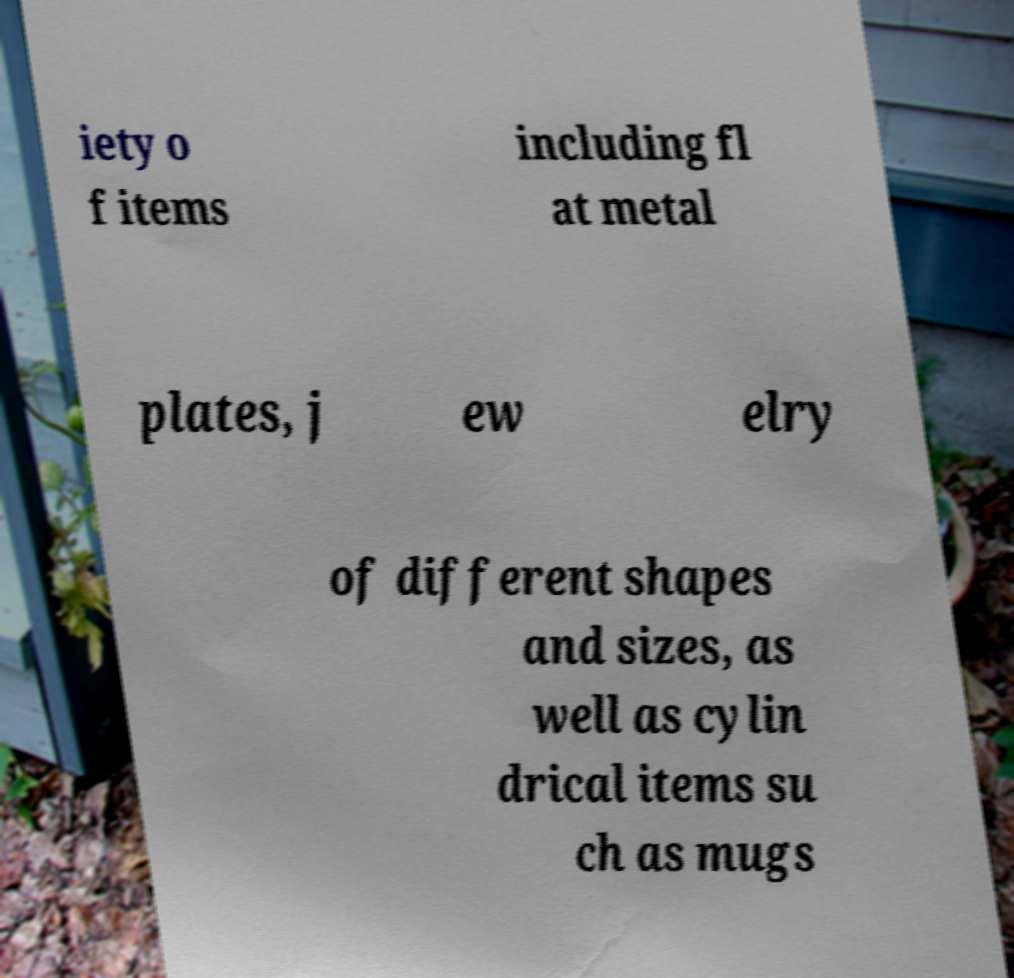For documentation purposes, I need the text within this image transcribed. Could you provide that? iety o f items including fl at metal plates, j ew elry of different shapes and sizes, as well as cylin drical items su ch as mugs 